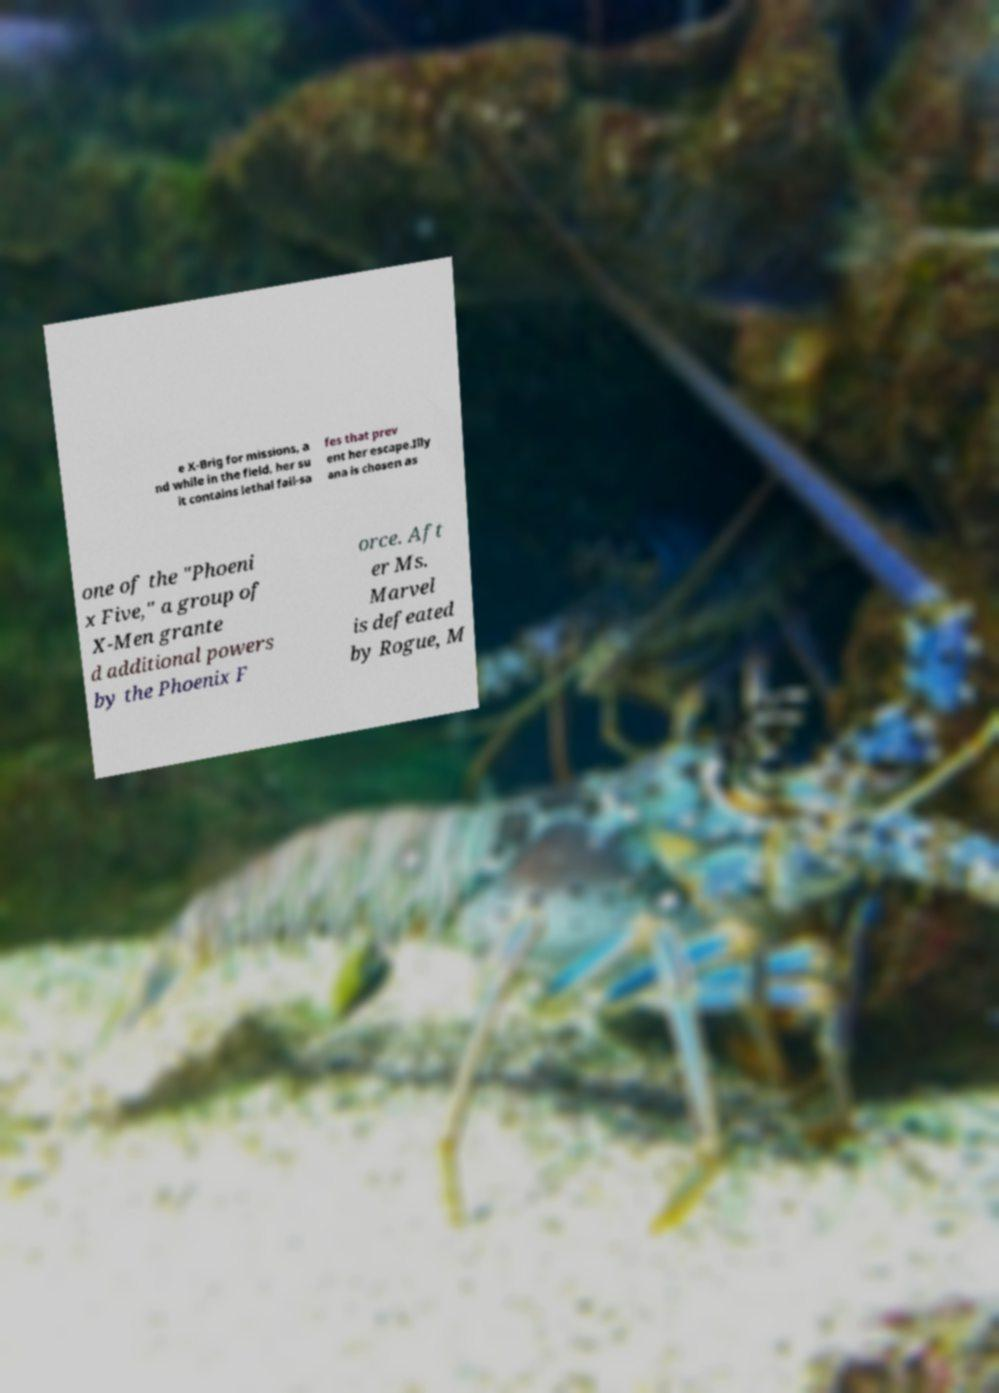Can you accurately transcribe the text from the provided image for me? e X-Brig for missions, a nd while in the field, her su it contains lethal fail-sa fes that prev ent her escape.Illy ana is chosen as one of the "Phoeni x Five," a group of X-Men grante d additional powers by the Phoenix F orce. Aft er Ms. Marvel is defeated by Rogue, M 